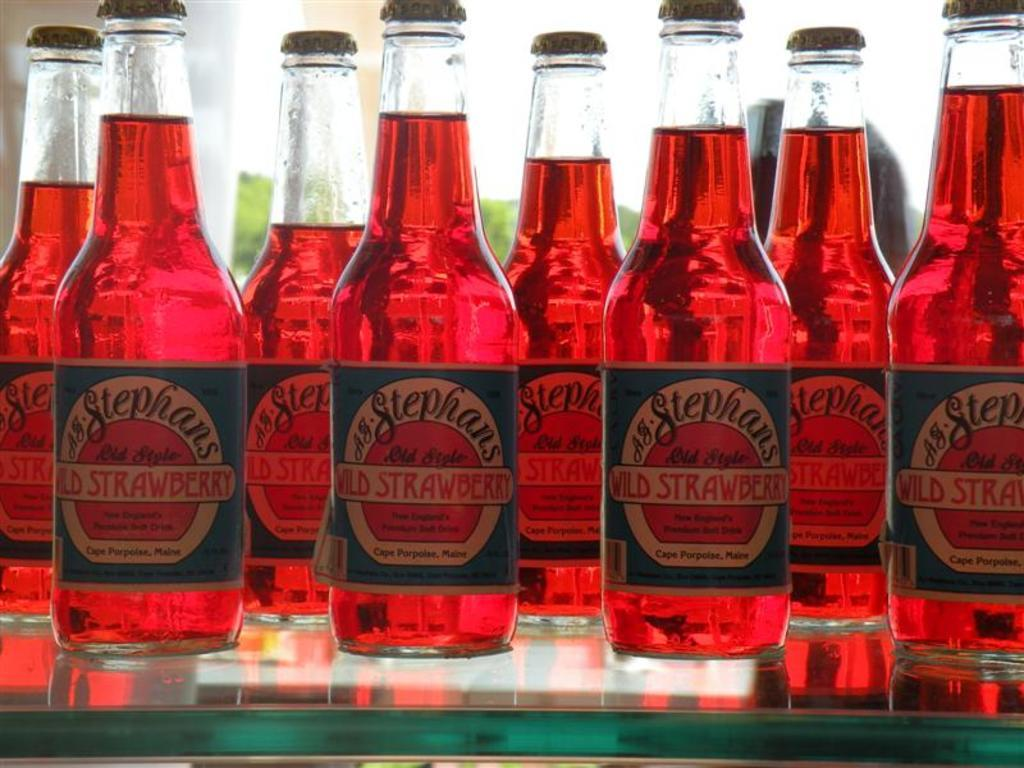What is the main subject of the image? The main subject of the image is many bottles. What is inside the bottles? The bottles contain a red liquid. Is there a parcel being delivered by a courier in the image? There is no mention or indication of a parcel or courier in the image. Is there a party happening in the image? There is no indication of a party or any celebratory event in the image. Can you see the father of the person who took the picture in the image? There is no information about the person who took the picture or their father in the image. 